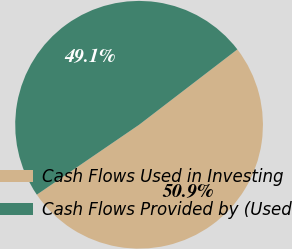Convert chart to OTSL. <chart><loc_0><loc_0><loc_500><loc_500><pie_chart><fcel>Cash Flows Used in Investing<fcel>Cash Flows Provided by (Used<nl><fcel>50.87%<fcel>49.13%<nl></chart> 